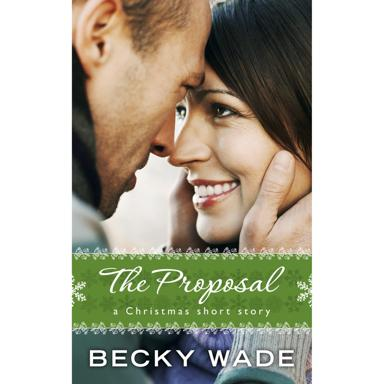What might be the significance of the background design? The green banner in the background, adorned with subtle snowflake motifs, hints at a Christmas theme which could symbolize a time of celebration, family, and love. This design choice sets a festive tone and frames the couple in a moment that could be related to the holiday spirit, perhaps reflecting a pivotal scene from 'The Proposal' short story by Becky Wade. 